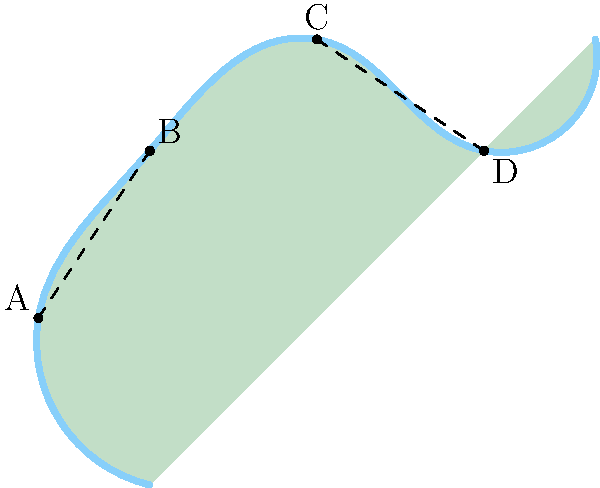The Mersey River meanders through the countryside, creating scenic bends. In the diagram above, which represents a section of the river, segments AB and CD appear to be congruent. If the length of AB is 32 meters, and the total distance along the river from A to D is 128 meters, what is the length of segment BC? Let's approach this step-by-step:

1) We're told that segments AB and CD are congruent. This means they have the same length.

2) We're given that the length of AB is 32 meters. Therefore, CD is also 32 meters.

3) The total distance along the river from A to D is 128 meters. This distance consists of three segments: AB, BC, and CD.

4) We can set up an equation:
   $AB + BC + CD = 128$

5) Substituting the known values:
   $32 + BC + 32 = 128$

6) Simplifying:
   $64 + BC = 128$

7) Subtracting 64 from both sides:
   $BC = 128 - 64 = 64$

Therefore, the length of segment BC is 64 meters.
Answer: 64 meters 